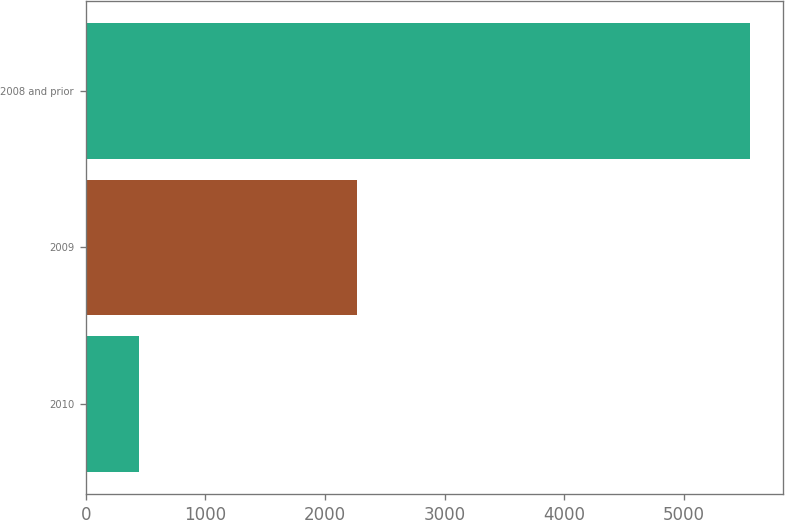Convert chart. <chart><loc_0><loc_0><loc_500><loc_500><bar_chart><fcel>2010<fcel>2009<fcel>2008 and prior<nl><fcel>446<fcel>2270<fcel>5551<nl></chart> 